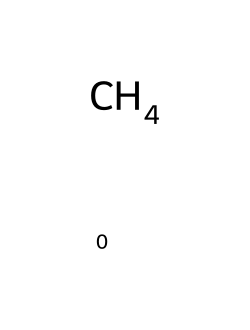What is the molecular formula of this compound? The SMILES representation "C" indicates a single carbon atom with no other atoms or bonds present, leading to the molecular formula of methane being CH4.
Answer: CH4 How many hydrogen atoms are connected to the carbon atom in this molecule? In the chemical structure represented by "C", the carbon atom is bonded to four hydrogen atoms, which is characteristic of methane.
Answer: 4 What is the total number of atoms in the molecule? This molecule consists of one carbon atom and four hydrogen atoms, so the total number of atoms is 1 + 4 = 5.
Answer: 5 Is this compound polar or non-polar? Methane has a symmetrical tetrahedral structure with an equal distribution of charge, which makes it non-polar.
Answer: non-polar What type of bonding occurs in methane? The bonds formed between carbon and hydrogen in methane are covalent bonds, characterized by sharing of electrons.
Answer: covalent What is the primary reason methane is classified as a greenhouse gas? Methane has a high global warming potential due to its ability to effectively trap heat in the atmosphere, primarily because of its molecular structure.
Answer: heat trapping What is a unique property of non-electrolytes like methane in terms of solubility? Non-electrolytes do not dissociate into ions in solution and are generally less soluble in water, as methane is a gas that does not ionize.
Answer: low water solubility 